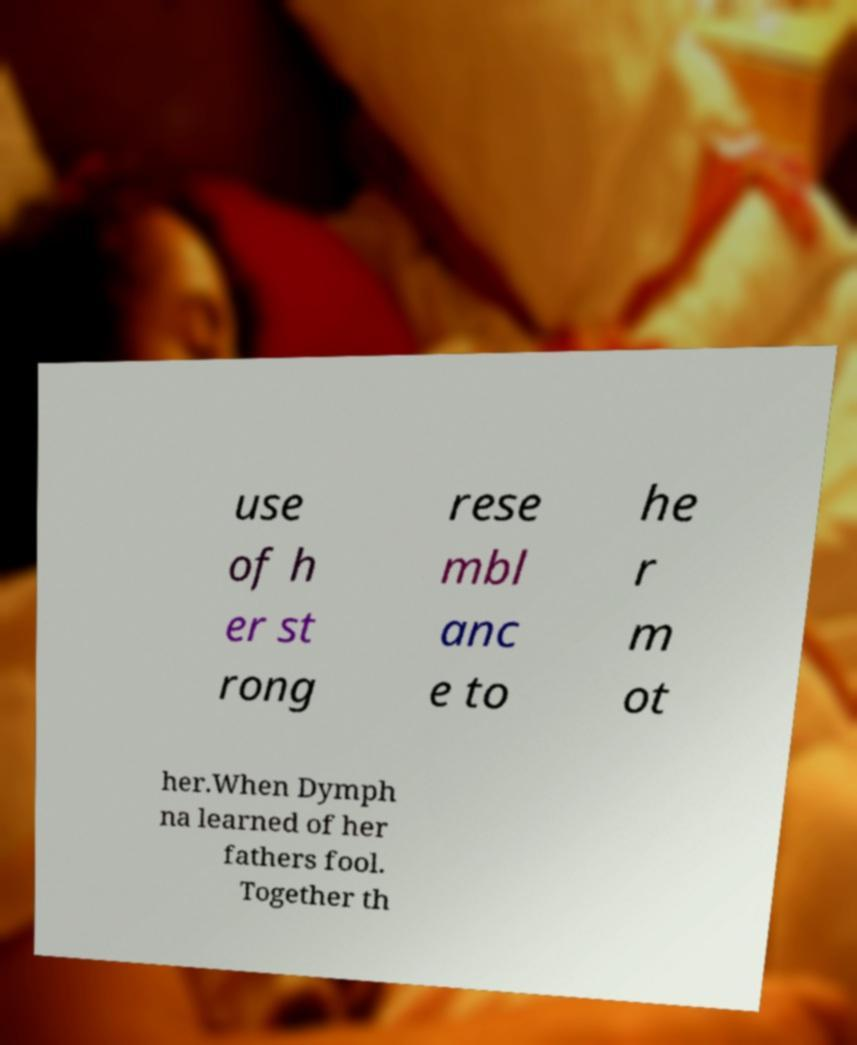Please read and relay the text visible in this image. What does it say? use of h er st rong rese mbl anc e to he r m ot her.When Dymph na learned of her fathers fool. Together th 